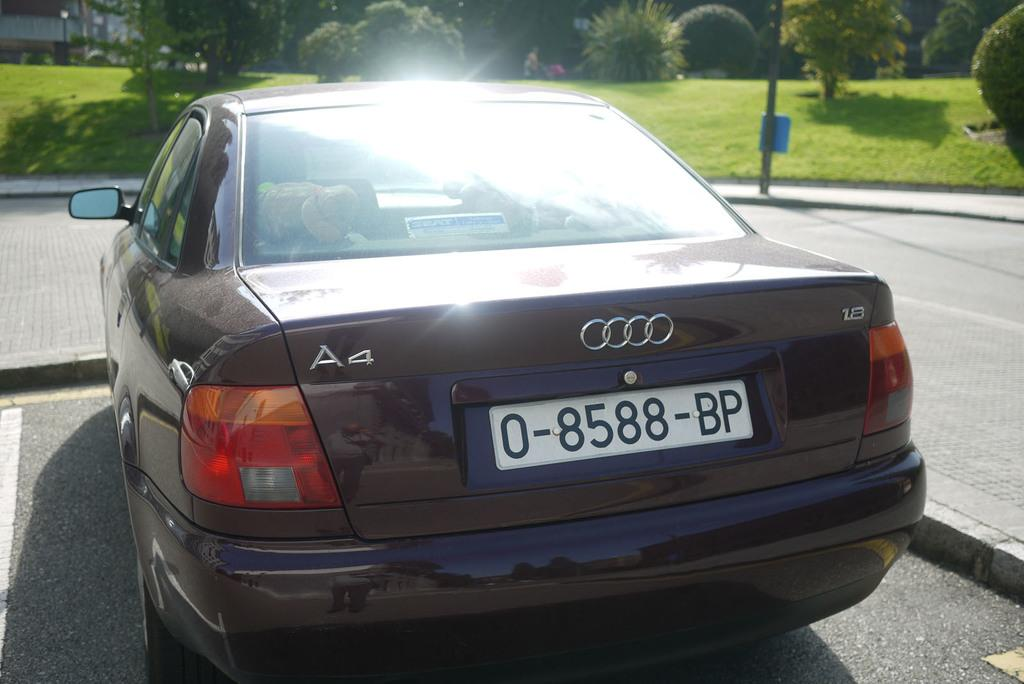Provide a one-sentence caption for the provided image. A small brown sedan with A4 on the top left side. 